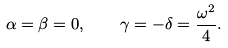Convert formula to latex. <formula><loc_0><loc_0><loc_500><loc_500>\alpha = \beta = 0 , \quad \gamma = - \delta = \frac { \omega ^ { 2 } } 4 .</formula> 